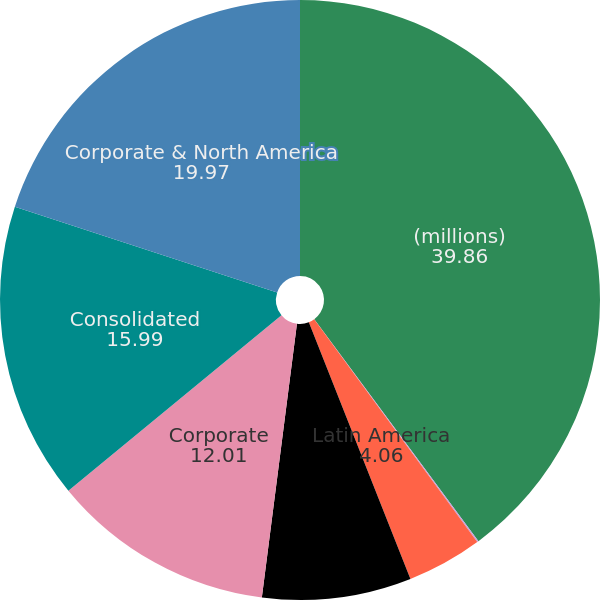<chart> <loc_0><loc_0><loc_500><loc_500><pie_chart><fcel>(millions)<fcel>Europe<fcel>Latin America<fcel>Asia Pacific<fcel>Corporate<fcel>Consolidated<fcel>Corporate & North America<nl><fcel>39.86%<fcel>0.08%<fcel>4.06%<fcel>8.03%<fcel>12.01%<fcel>15.99%<fcel>19.97%<nl></chart> 